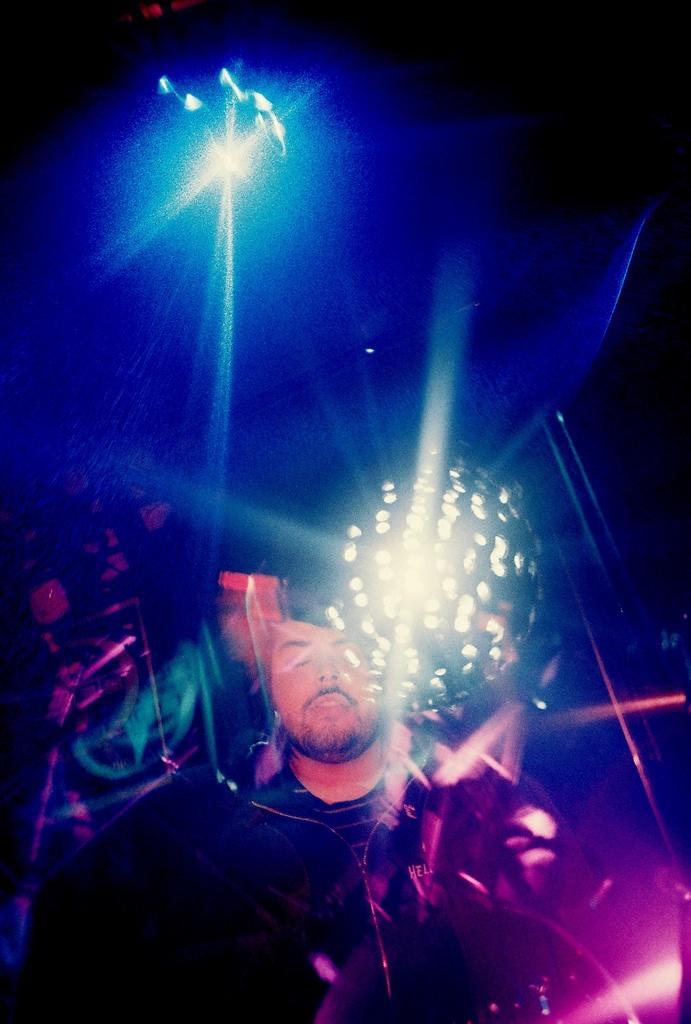Could you give a brief overview of what you see in this image? In this picture we can see a person. There are a few colorful lights in the background. 